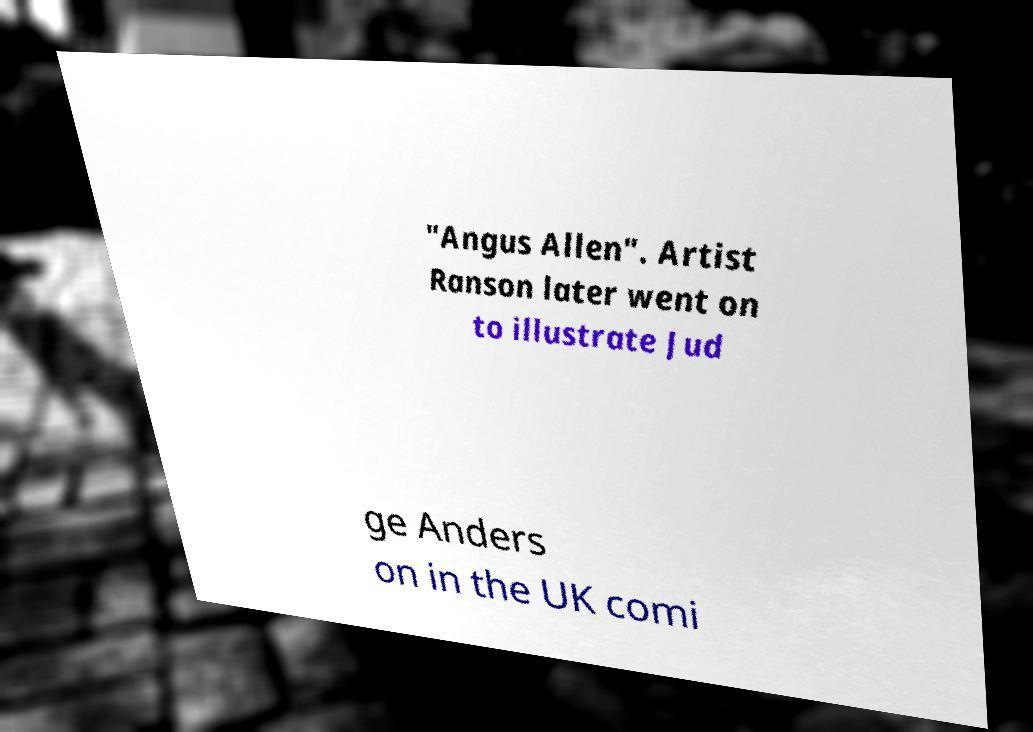Could you extract and type out the text from this image? "Angus Allen". Artist Ranson later went on to illustrate Jud ge Anders on in the UK comi 